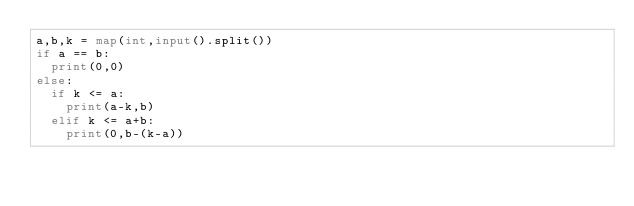<code> <loc_0><loc_0><loc_500><loc_500><_Python_>a,b,k = map(int,input().split())
if a == b:
	print(0,0)
else:
	if k <= a:
		print(a-k,b)
	elif k <= a+b:
		print(0,b-(k-a))</code> 